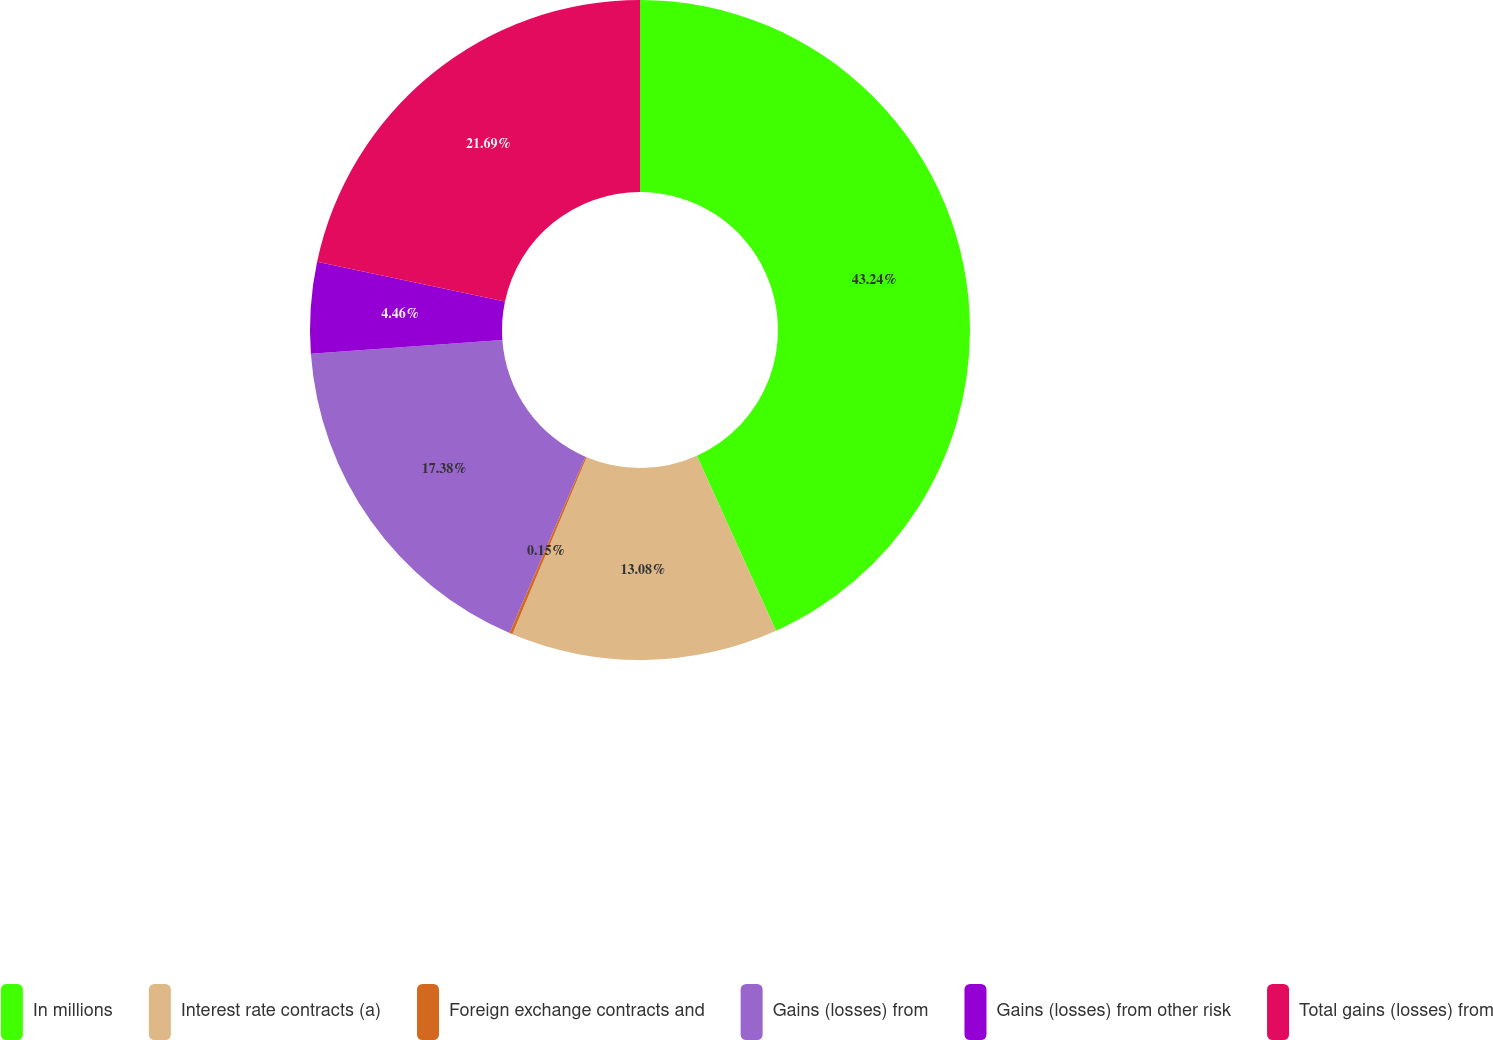Convert chart. <chart><loc_0><loc_0><loc_500><loc_500><pie_chart><fcel>In millions<fcel>Interest rate contracts (a)<fcel>Foreign exchange contracts and<fcel>Gains (losses) from<fcel>Gains (losses) from other risk<fcel>Total gains (losses) from<nl><fcel>43.24%<fcel>13.08%<fcel>0.15%<fcel>17.38%<fcel>4.46%<fcel>21.69%<nl></chart> 